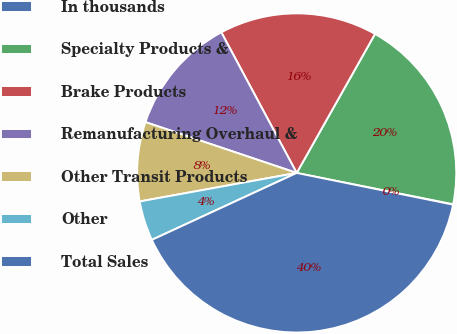<chart> <loc_0><loc_0><loc_500><loc_500><pie_chart><fcel>In thousands<fcel>Specialty Products &<fcel>Brake Products<fcel>Remanufacturing Overhaul &<fcel>Other Transit Products<fcel>Other<fcel>Total Sales<nl><fcel>0.04%<fcel>19.98%<fcel>16.0%<fcel>12.01%<fcel>8.02%<fcel>4.03%<fcel>39.93%<nl></chart> 